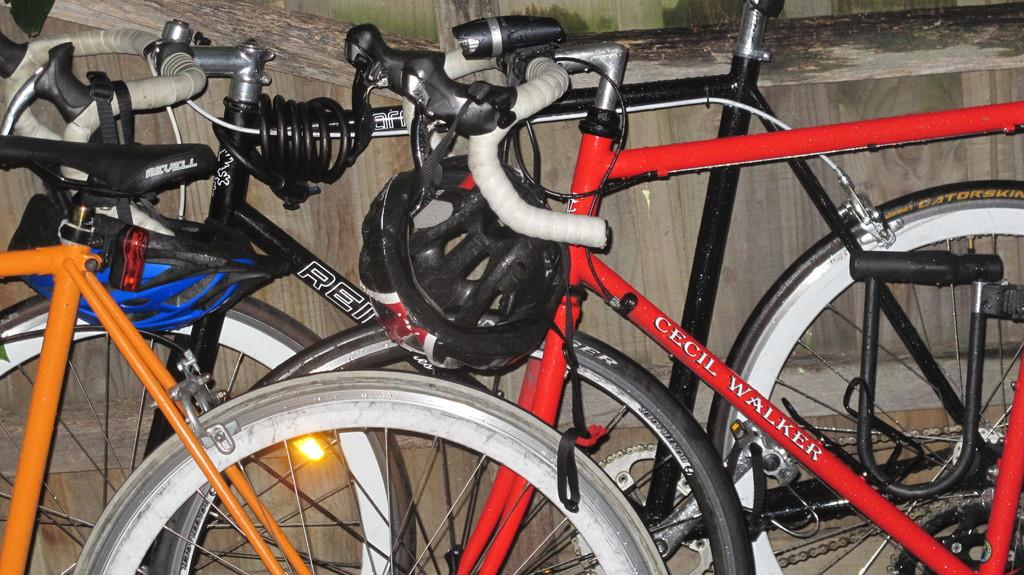What type of vehicles are in the image? There are cycles in the image. Where are the cycles located in relation to the wall? The cycles are placed near a wall. What colors can be seen on the cycles? Some cycles are red, black, and orange in color. What safety equipment is attached to the cycles? There are helmets attached to the handlebars of the cycles. What color are the helmets? The helmets are black in color. What type of creature can be seen sitting on the handlebars of the cycles? There is no creature present on the handlebars of the cycles in the image. Are there any flowers visible in the image? There are no flowers visible in the image. 